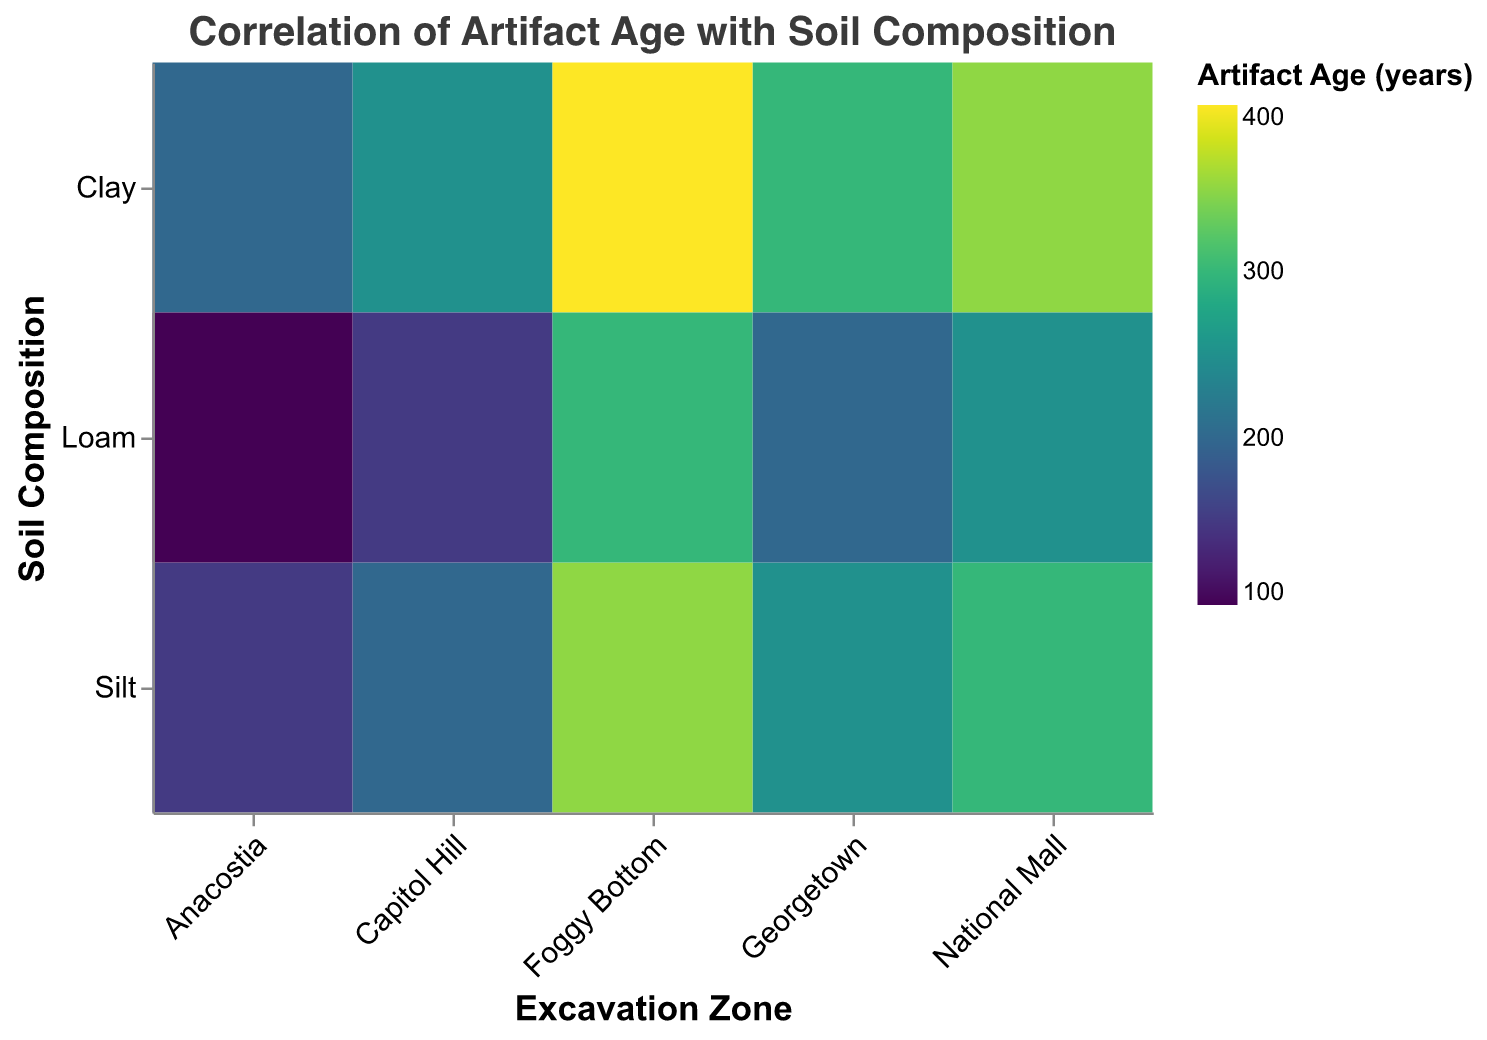What's the title of the figure? The title of the figure is displayed at the top center of the figure. It reads "Correlation of Artifact Age with Soil Composition".
Answer: Correlation of Artifact Age with Soil Composition Which Excavation Zone has the oldest artifact in Clay soil composition? To determine which Excavation Zone has the oldest artifact in the Clay soil composition, find the rectangle in the Clay row with the darkest color. The darkest color in the Clay row corresponds to the oldest artifact, and it is in the Foggy Bottom column.
Answer: Foggy Bottom What's the artifact age range for Silt soil in different Excavation Zones? Look at the Silt row and inspect the color gradient from lightest to darkest. The lightest color represents the youngest age, and the darkest represents the oldest. By checking the legend, the range can be identified between 150 (youngest) and 350 (oldest).
Answer: 150 to 350 Which soil composition in the Georgetown zone has the youngest artifacts? To find which soil composition in Georgetown has the youngest artifact, identify the color with the lightest shade within the Georgetown column. The lightest shade in Georgetown is in the Loam row indicating the youngest artifacts.
Answer: Loam Compare the artifact ages for Loam soil in the National Mall and Anacostia zones. To compare, find the colors in the Loam row for both National Mall and Anacostia columns. The color in National Mall is darker than the one in Anacostia, indicating that the artifacts in National Mall are older.
Answer: National Mall has older artifacts What is the difference in artifact age between Clay soil in Capitol Hill and Foggy Bottom? Locate the colors in the Clay row corresponding to Capitol Hill and Foggy Bottom columns. Using the legend, read their respective ages: Capitol Hill (250) and Foggy Bottom (400). The difference is 400 - 250.
Answer: 150 years Which Excavation Zone has the most uniform artifact age across all soil compositions? Inspect the columns to see which column has the most similar shades of color in its cells. The National Mall column has colors with the most uniform shades indicative of less variation in artifact ages across Clay, Silt, and Loam.
Answer: National Mall How does the artifact age in Loam soil in Anacostia compare to Silt soil in Capitol Hill? Identify the shades for Loam in Anacostia and Silt in Capitol Hill. Loam in Anacostia is lighter, indicating a younger age (100), while Silt in Capitol Hill is darker (200). Thus, Anacostia has younger artifacts.
Answer: Anacostia is younger What can you infer about the correlation between soil composition and artifact age in general? Observe the overall color gradients across all soil compositions and zones. Generally, Clay has the oldest artifacts, followed by Silt, and then Loam having the youngest. This indicates a trend where artifact age decreases from Clay to Loam.
Answer: Artifact age generally decreases from Clay to Loam 